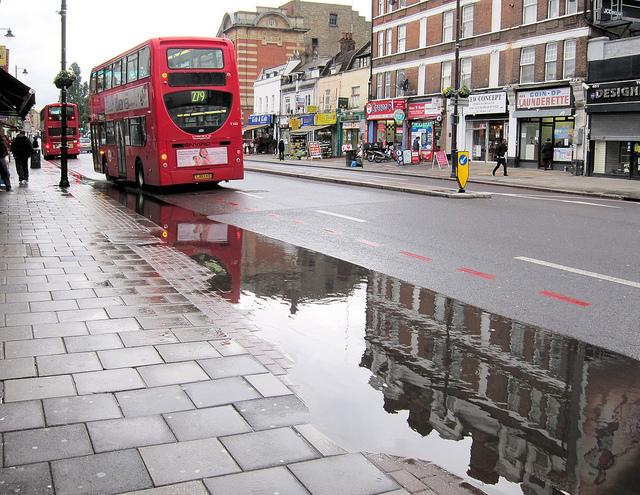If you wanted to wash clothes near here what would you need? coins 